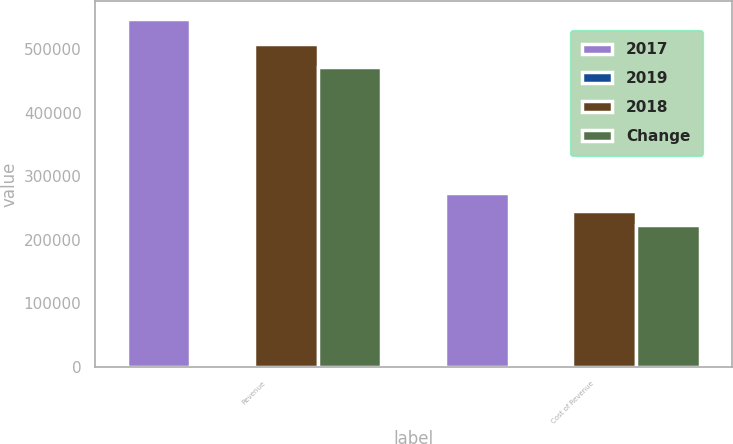Convert chart to OTSL. <chart><loc_0><loc_0><loc_500><loc_500><stacked_bar_chart><ecel><fcel>Revenue<fcel>Cost of Revenue<nl><fcel>2017<fcel>548319<fcel>273261<nl><fcel>2019<fcel>8<fcel>11<nl><fcel>2018<fcel>508331<fcel>245269<nl><fcel>Change<fcel>471988<fcel>222685<nl></chart> 